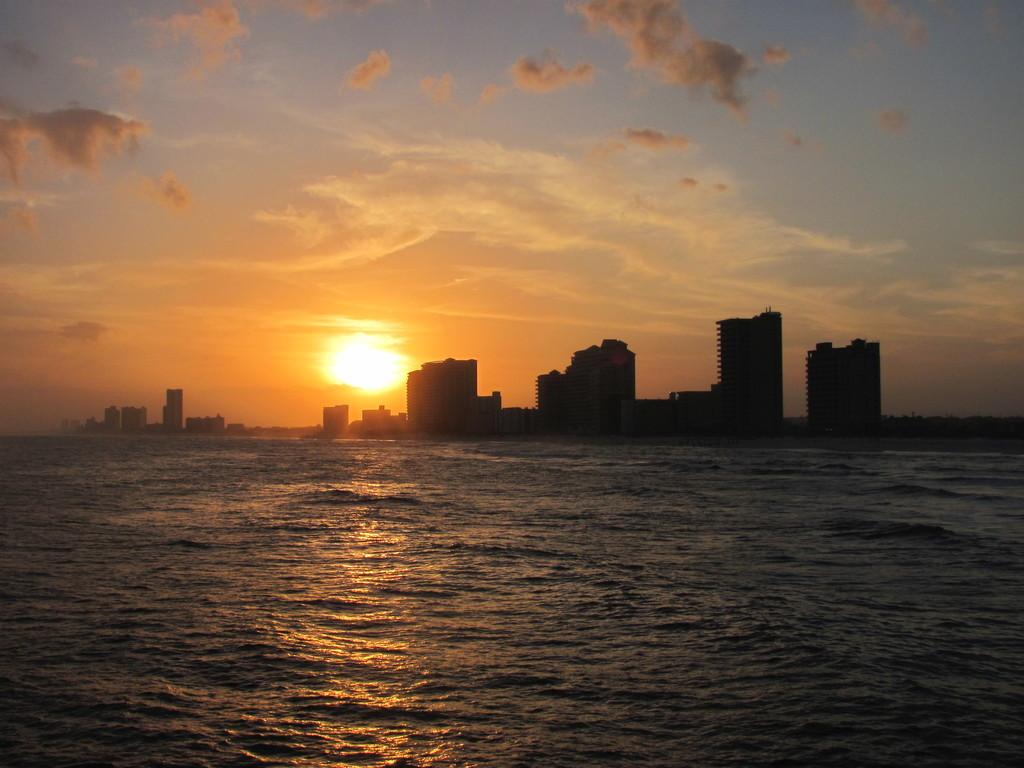What is visible in the image? Water is visible in the image. What can be seen in the distance in the image? There are buildings in the background of the image. How would you describe the sky in the image? The sky appears to be cloudy in the background. What time of day might the image depict? The image seems to depict a sunrise. What type of disease is spreading among the passengers in the image? There are no passengers present in the image, and therefore no disease can be observed. 